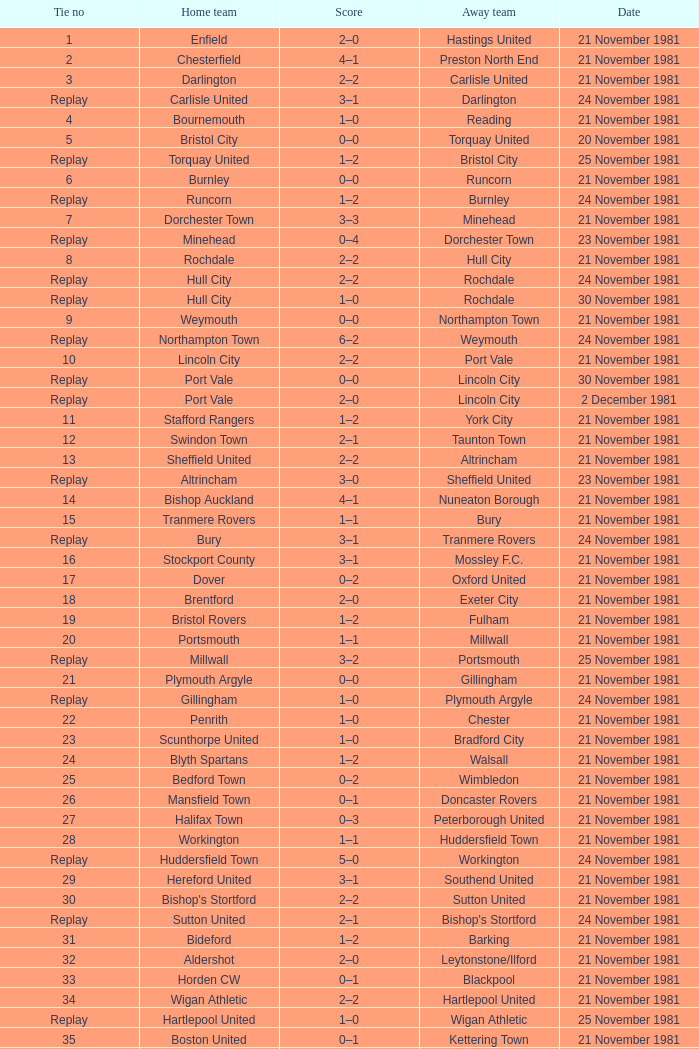What was the date for tie number 4? 21 November 1981. 